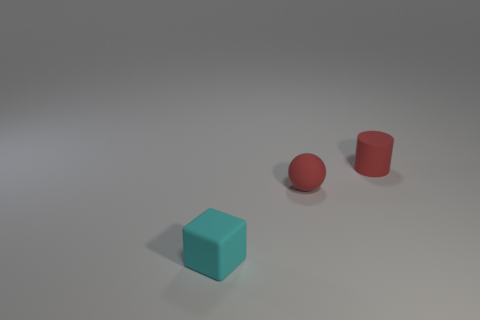Add 3 big cyan metallic cylinders. How many objects exist? 6 Subtract all blocks. How many objects are left? 2 Add 2 big shiny spheres. How many big shiny spheres exist? 2 Subtract 0 gray cylinders. How many objects are left? 3 Subtract all gray rubber cylinders. Subtract all tiny red objects. How many objects are left? 1 Add 2 balls. How many balls are left? 3 